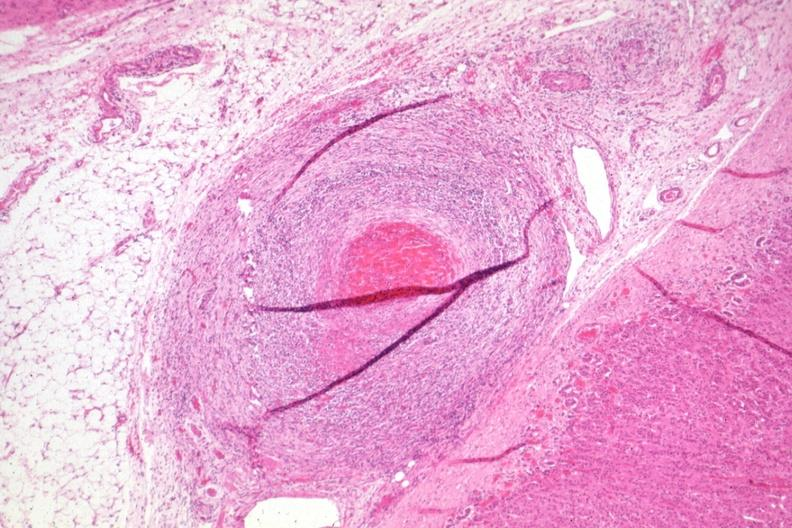what has folds?
Answer the question using a single word or phrase. Healing lesion in medium size artery just outside adrenal capsule section 